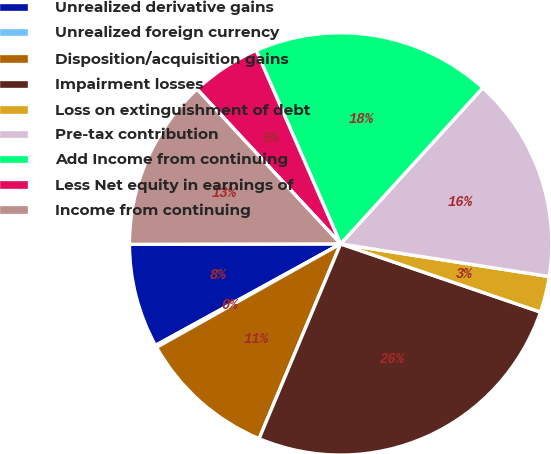Convert chart. <chart><loc_0><loc_0><loc_500><loc_500><pie_chart><fcel>Unrealized derivative gains<fcel>Unrealized foreign currency<fcel>Disposition/acquisition gains<fcel>Impairment losses<fcel>Loss on extinguishment of debt<fcel>Pre-tax contribution<fcel>Add Income from continuing<fcel>Less Net equity in earnings of<fcel>Income from continuing<nl><fcel>7.95%<fcel>0.17%<fcel>10.54%<fcel>26.08%<fcel>2.76%<fcel>15.72%<fcel>18.31%<fcel>5.35%<fcel>13.13%<nl></chart> 